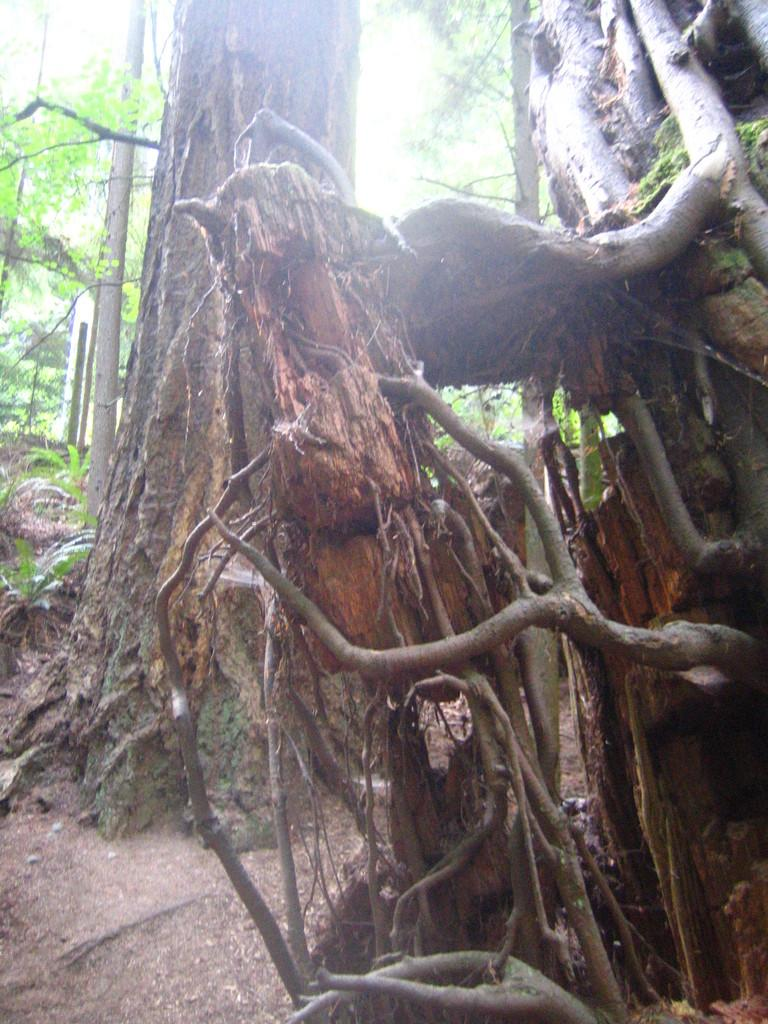What type of plant material is shown in the image? There are dry roots of a tree in the image. What other part of the tree can be seen in the image? There is a tree trunk visible in the background of the image. What is the color and condition of the leaves in the image? There are green leaves present in the background of the image. What type of amusement can be seen in the image? There is no amusement present in the image; it features dry tree roots, a tree trunk, and green leaves. How many snails are crawling on the tree roots in the image? There are no snails visible in the image. 